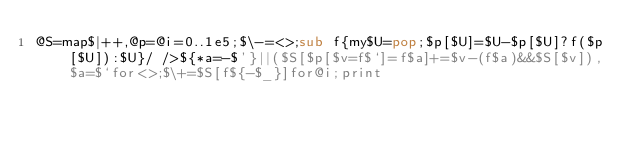<code> <loc_0><loc_0><loc_500><loc_500><_Perl_>@S=map$|++,@p=@i=0..1e5;$\-=<>;sub f{my$U=pop;$p[$U]=$U-$p[$U]?f($p[$U]):$U}/ />${*a=-$'}||($S[$p[$v=f$`]=f$a]+=$v-(f$a)&&$S[$v]),$a=$`for<>;$\+=$S[f${-$_}]for@i;print</code> 